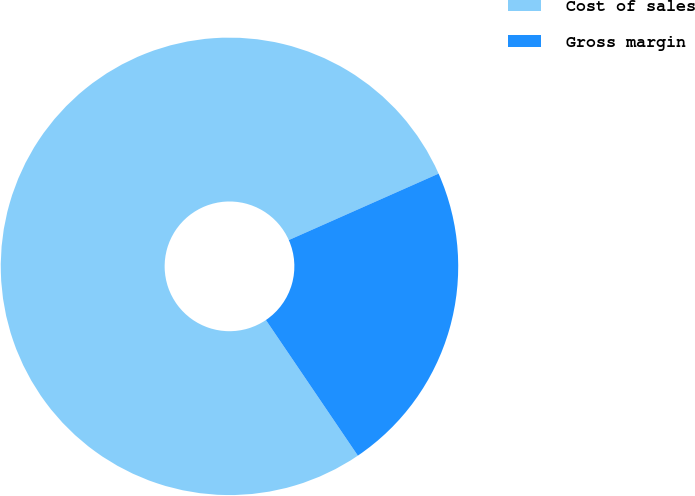<chart> <loc_0><loc_0><loc_500><loc_500><pie_chart><fcel>Cost of sales<fcel>Gross margin<nl><fcel>77.84%<fcel>22.16%<nl></chart> 